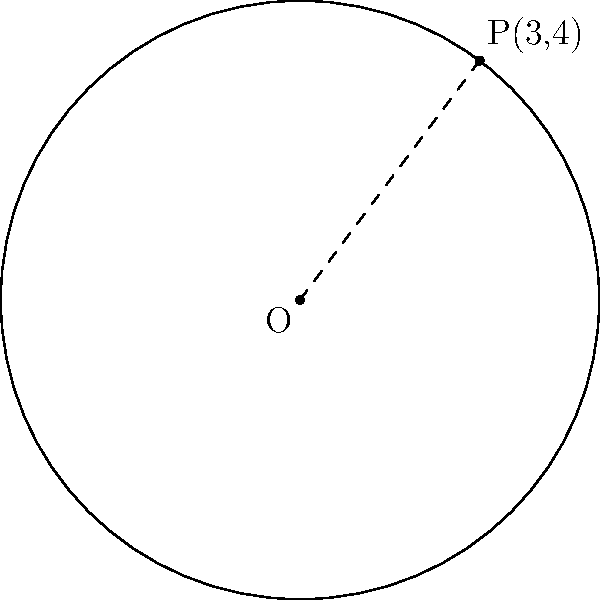Your mentor has challenged you to solve a geometry problem related to circles. Given a circle with center O at the origin (0,0) and a point P(3,4) on its circumference, determine the equation of the circle. How would you approach this problem and what would be the final equation? Let's approach this step-by-step:

1) The general equation of a circle is $(x-h)^2 + (y-k)^2 = r^2$, where (h,k) is the center and r is the radius.

2) We're given that the center is at the origin (0,0), so h = 0 and k = 0. This simplifies our equation to:

   $x^2 + y^2 = r^2$

3) To find $r^2$, we can use the point P(3,4) on the circumference. The distance between this point and the center is the radius.

4) We can calculate this using the distance formula:

   $r^2 = (x - 0)^2 + (y - 0)^2 = 3^2 + 4^2 = 9 + 16 = 25$

5) Now we have $r^2 = 25$, so our equation becomes:

   $x^2 + y^2 = 25$

This is the equation of the circle.
Answer: $x^2 + y^2 = 25$ 